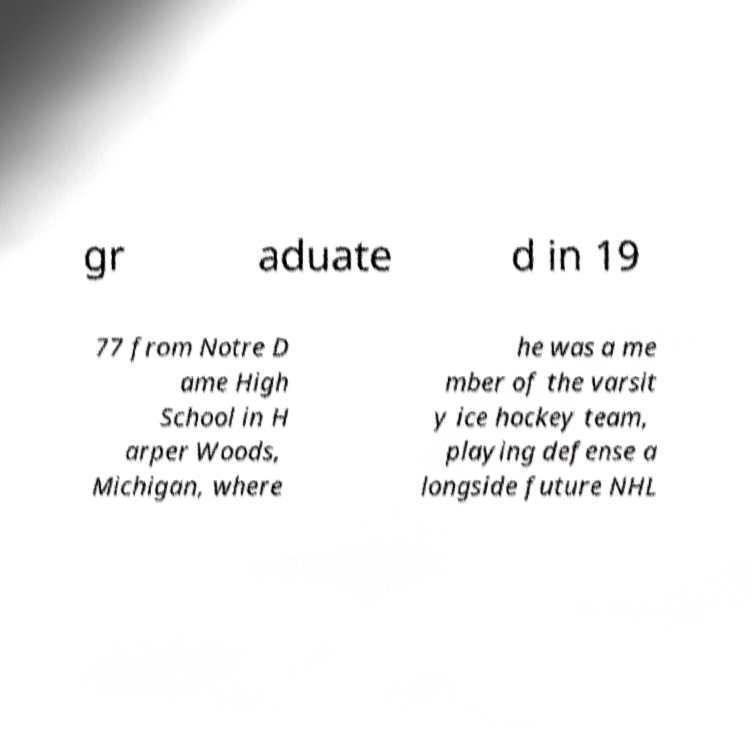For documentation purposes, I need the text within this image transcribed. Could you provide that? gr aduate d in 19 77 from Notre D ame High School in H arper Woods, Michigan, where he was a me mber of the varsit y ice hockey team, playing defense a longside future NHL 